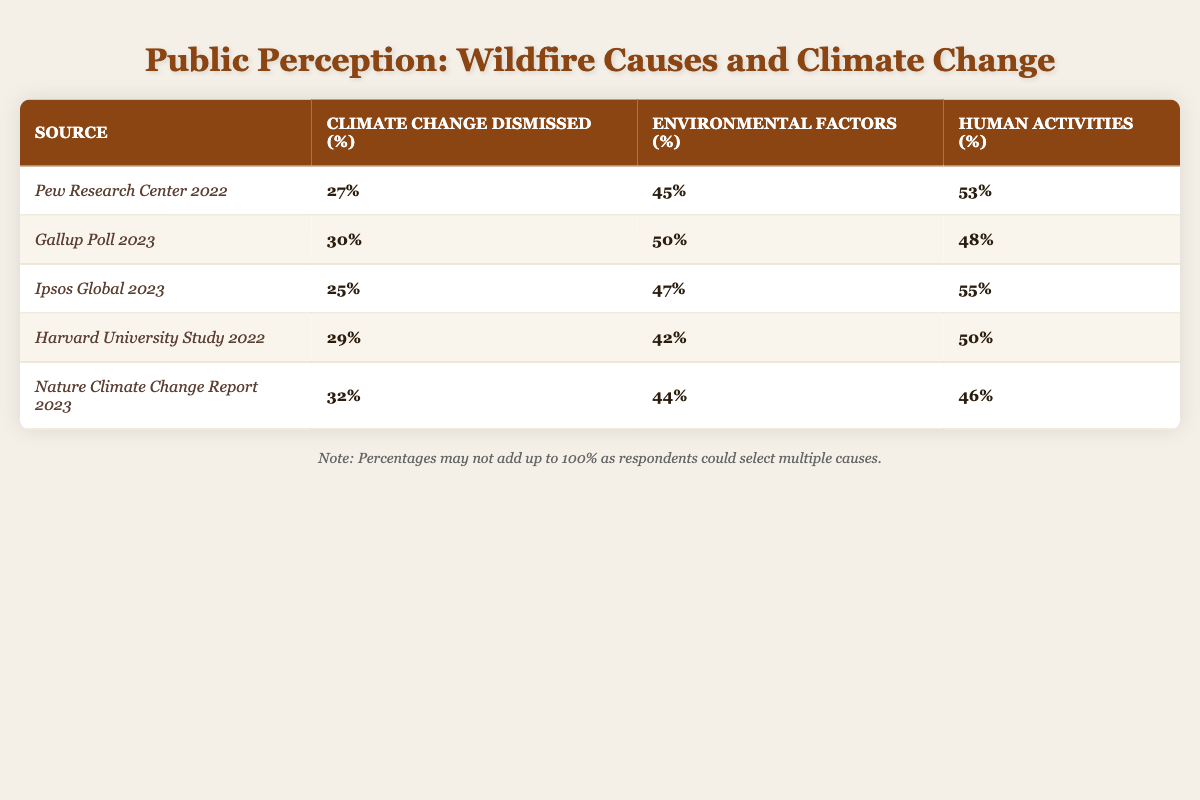What percentage of respondents dismissed climate change as a cause of wildfires according to the Pew Research Center? The table lists the specific percentage under the source "Pew Research Center 2022," which is 27%.
Answer: 27% Which survey showed the highest percentage of respondents attributing wildfires to human activities? In the table, Ipsos Global 2023 shows 55%, which is the highest percentage across all surveys for human activities as a cause of wildfires.
Answer: 55% What is the average percentage of respondents who dismissed climate change across all listed surveys? To find the average, add the percentages (27 + 30 + 25 + 29 + 32) = 143 and divide by the number of surveys, which is 5. Thus, 143 / 5 = 28.6%.
Answer: 28.6% Was there any survey where more than 50% of respondents attributed wildfires to environmental factors? By examining the table, it is seen that the Gallup Poll 2023 shows 50% and all others are at or below that, indicating no survey reached above 50%.
Answer: No How does the percentage of respondents who cited environmental factors compare to those who dismissed climate change in the Nature Climate Change Report 2023? Under "Nature Climate Change Report 2023," the percentage for environmental factors is 44%, while for dismissing climate change it is 32%. Comparing these, environmental factors (44%) are higher than the dismissal of climate change (32%).
Answer: Environmental factors (44%) are higher than dismissed climate change (32%) In which survey was the difference between the percentage of dismissed climate change and human activities the largest? For each survey, calculate the difference by subtracting the percentage of climate change dismissed from the percentage of human activities. The largest difference is in the Pew Research Center 2022, which is 53% (human activities) - 27% (dismissed climate change) = 26%.
Answer: Pew Research Center 2022 What trend do you observe in the dismissal of climate change as a cause of wildfires over the years among the surveys? By observing the percentages from 2022 to 2023, there's a slight increase from 27% in 2022 (Pew) to 32% in 2023 (Nature Climate Change), indicating that more people seem to dismiss climate change in recent surveys.
Answer: Slight increase in dismissal How do the percentages for environmental factors compare across the surveys? The environmental factor percentages are 45%, 50%, 47%, 42%, and 44% respectively, indicating a general range without consistent trends, but the highest is from Gallup Poll 2023 at 50%.
Answer: Gallup Poll 2023 is the highest at 50% 